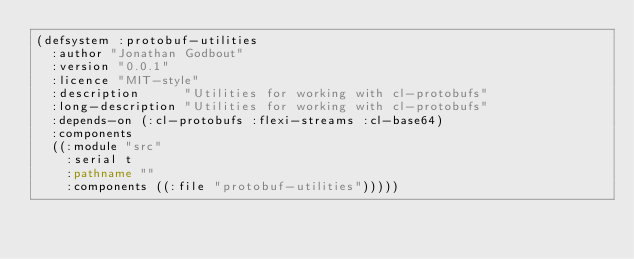<code> <loc_0><loc_0><loc_500><loc_500><_Lisp_>(defsystem :protobuf-utilities
  :author "Jonathan Godbout"
  :version "0.0.1"
  :licence "MIT-style"
  :description      "Utilities for working with cl-protobufs"
  :long-description "Utilities for working with cl-protobufs"
  :depends-on (:cl-protobufs :flexi-streams :cl-base64)
  :components
  ((:module "src"
    :serial t
    :pathname ""
    :components ((:file "protobuf-utilities")))))
</code> 